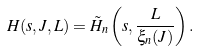<formula> <loc_0><loc_0><loc_500><loc_500>H ( s , J , L ) = \tilde { H } _ { n } \left ( s , \frac { L } { \xi _ { n } ( J ) } \right ) .</formula> 